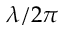Convert formula to latex. <formula><loc_0><loc_0><loc_500><loc_500>\lambda / 2 \pi</formula> 